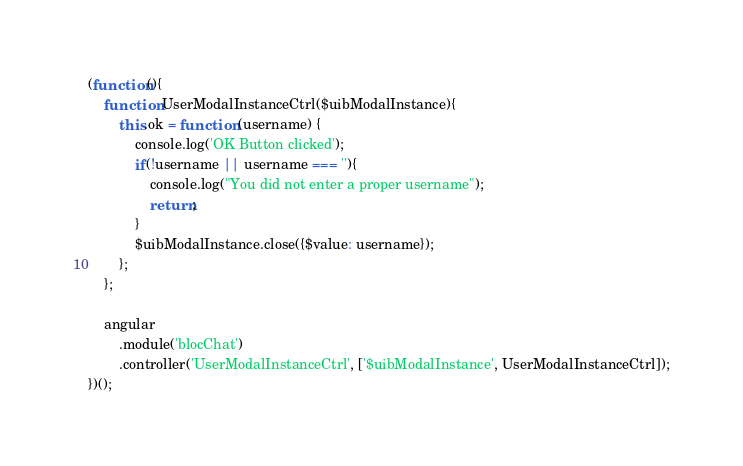<code> <loc_0><loc_0><loc_500><loc_500><_JavaScript_>(function(){
    function UserModalInstanceCtrl($uibModalInstance){
        this.ok = function (username) {
            console.log('OK Button clicked');
            if(!username || username === ''){
                console.log("You did not enter a proper username");
                return;
            }
            $uibModalInstance.close({$value: username});
        };
    };

    angular
        .module('blocChat')
        .controller('UserModalInstanceCtrl', ['$uibModalInstance', UserModalInstanceCtrl]);
})();
</code> 